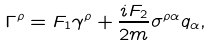<formula> <loc_0><loc_0><loc_500><loc_500>\Gamma ^ { \rho } = F _ { 1 } \gamma ^ { \rho } + \frac { i F _ { 2 } } { 2 m } \sigma ^ { \rho \alpha } q _ { \alpha } ,</formula> 